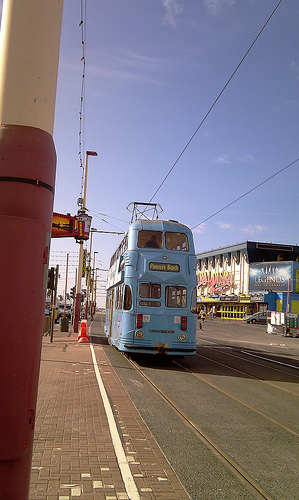<image>
Can you confirm if the wire is to the right of the bus? No. The wire is not to the right of the bus. The horizontal positioning shows a different relationship. 